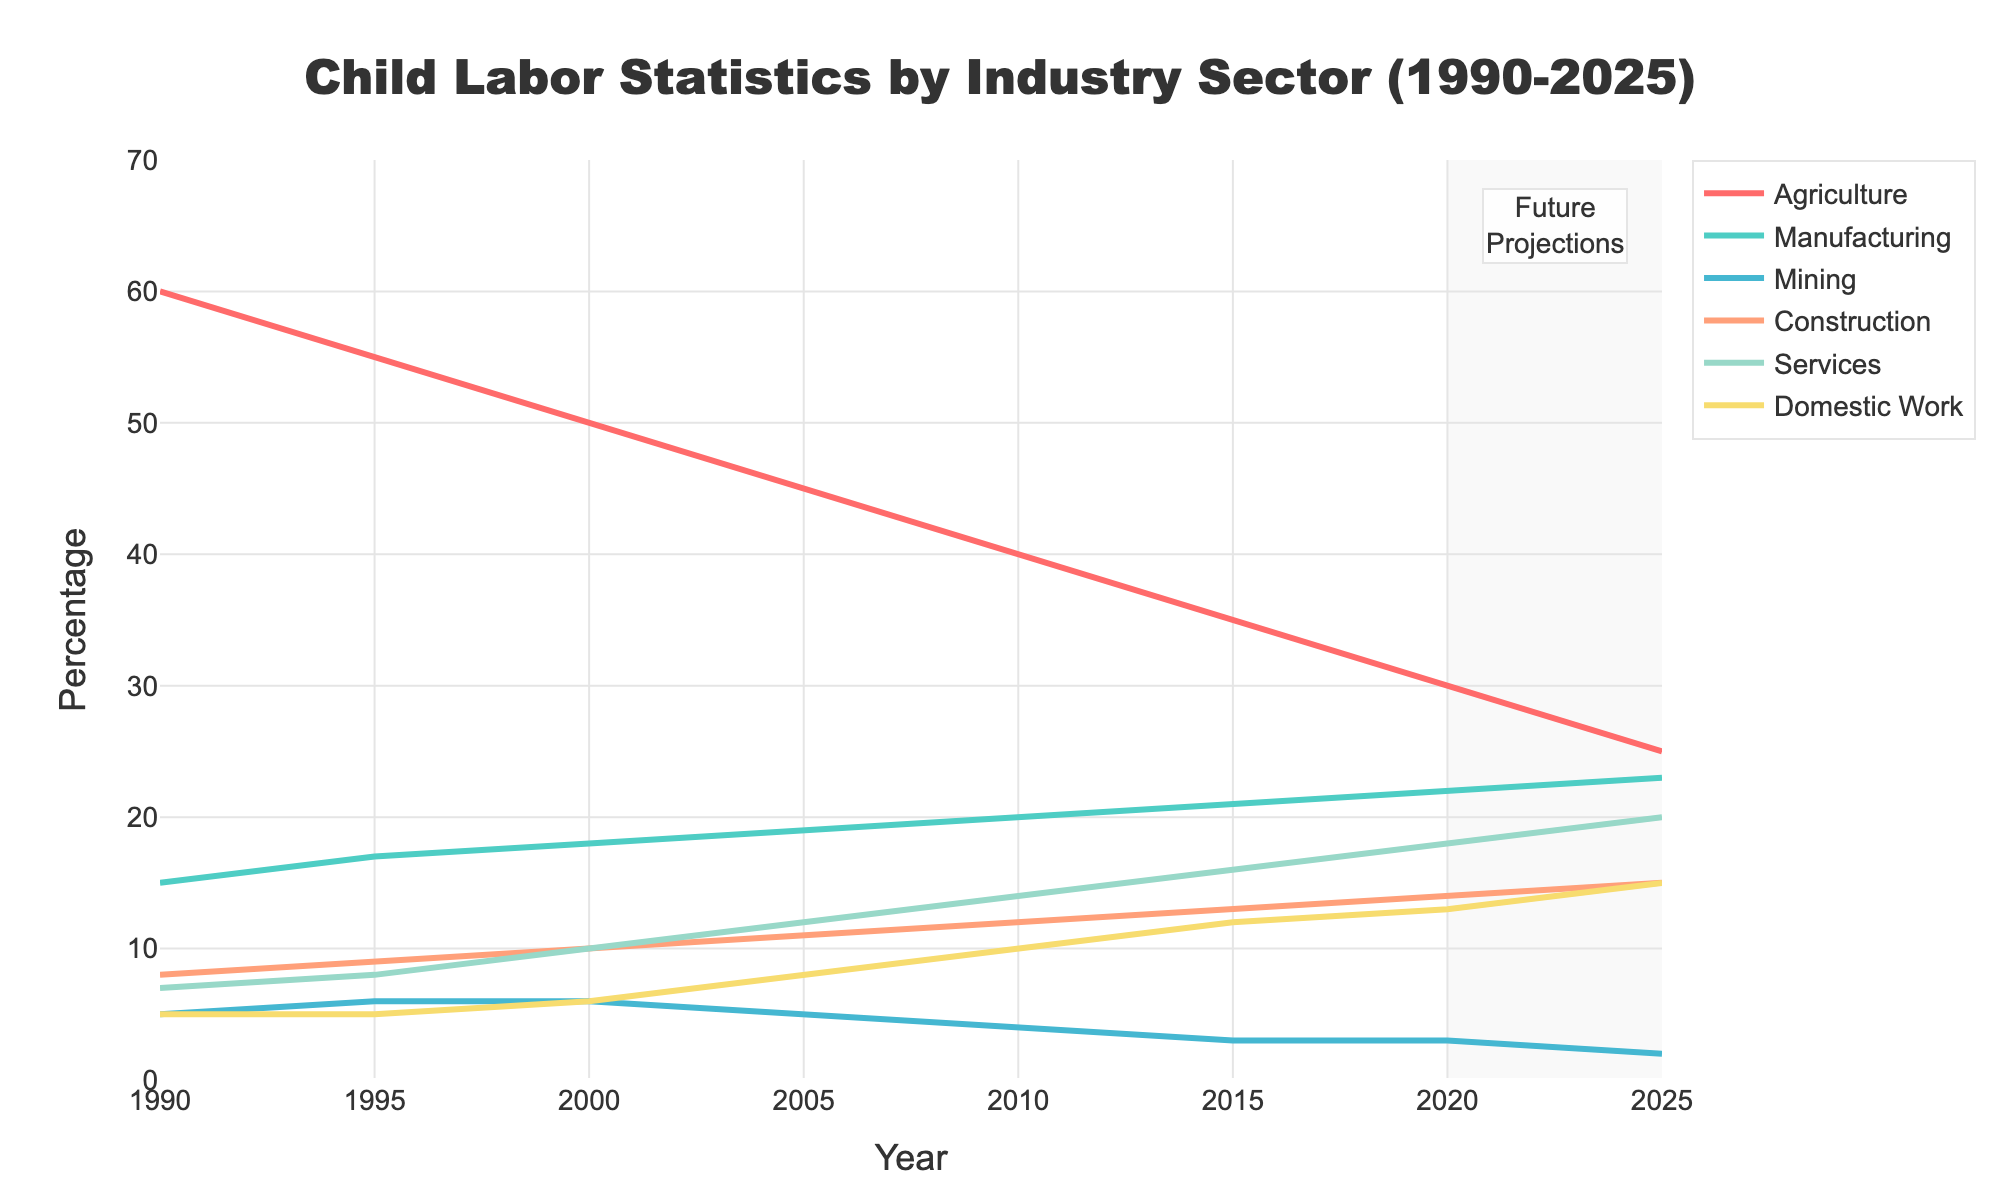What is the title of the plot? The title is always displayed at the top of the figure, centered and bold for emphasis. In this case, look at the top center of the plot.
Answer: Child Labor Statistics by Industry Sector (1990-2025) What year does the data start at? The starting year can be found on the x-axis at the far left end.
Answer: 1990 Which industry sector had the highest percentage of child labor in 2000? Find the data points corresponding to the year 2000 on the x-axis and check the y-values of the lines. The highest point will indicate the leading sector.
Answer: Agriculture In which year did the Manufacturing sector surpass the Agriculture sector for child labor percentage? Observe the intersection of the Manufacturing (green line) and Agriculture (red line) trends. Note the year on the x-axis where the Manufacturing line surpasses the Agriculture line.
Answer: Never What is the percentage change in child labor in the Services sector from 1990 to 2025? Locate the starting (1990) and ending (2025) values for the Services sector (blue line) and calculate the difference: 20 - 7 = 13.
Answer: 13% Between 2015 and 2020, which sector showed the smallest change in child labor percentage? Compare the y-values for each sector between 2015 and 2020, looking for the smallest difference.
Answer: Mining Which industry is expected to have a declining trend in the future projections from 2020 to 2025? Examine the trends in the shaded future projection area (2020-2025) and identify the line(s) that show a downward slope.
Answer: Agriculture How does the trend of Domestic Work compare to Services from 1995 to 2010? Observe the lines for Domestic Work (yellow) and Services (blue) between 1995 and 2010, noting their slopes and trends. Domestic Work rises more steeply.
Answer: Domestic Work rises more sharply than Services What is the combined percentage of child labor for Agriculture and Mining in 2010? Find the y-values for Agriculture and Mining in 2010 and add them together: 40 (Agriculture) + 4 (Mining) = 44.
Answer: 44% How many industry sectors have a percentage of child labor below 5% in the year 2025? Look at the data points for the year 2025 and count the number of lines that fall below the y-axis value of 5%.
Answer: 3 